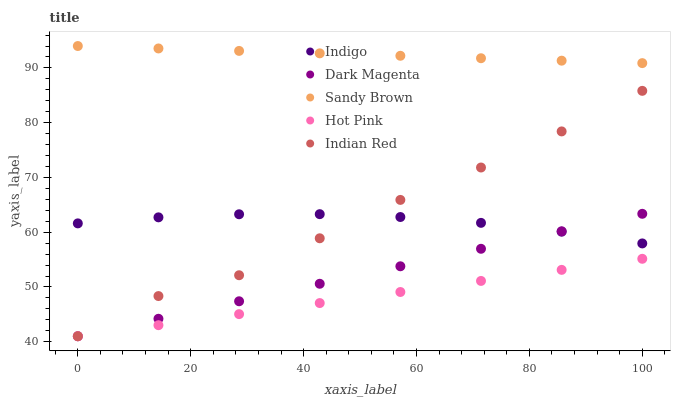Does Hot Pink have the minimum area under the curve?
Answer yes or no. Yes. Does Sandy Brown have the maximum area under the curve?
Answer yes or no. Yes. Does Indigo have the minimum area under the curve?
Answer yes or no. No. Does Indigo have the maximum area under the curve?
Answer yes or no. No. Is Hot Pink the smoothest?
Answer yes or no. Yes. Is Indian Red the roughest?
Answer yes or no. Yes. Is Indigo the smoothest?
Answer yes or no. No. Is Indigo the roughest?
Answer yes or no. No. Does Hot Pink have the lowest value?
Answer yes or no. Yes. Does Indigo have the lowest value?
Answer yes or no. No. Does Sandy Brown have the highest value?
Answer yes or no. Yes. Does Indigo have the highest value?
Answer yes or no. No. Is Dark Magenta less than Sandy Brown?
Answer yes or no. Yes. Is Indigo greater than Hot Pink?
Answer yes or no. Yes. Does Dark Magenta intersect Hot Pink?
Answer yes or no. Yes. Is Dark Magenta less than Hot Pink?
Answer yes or no. No. Is Dark Magenta greater than Hot Pink?
Answer yes or no. No. Does Dark Magenta intersect Sandy Brown?
Answer yes or no. No. 